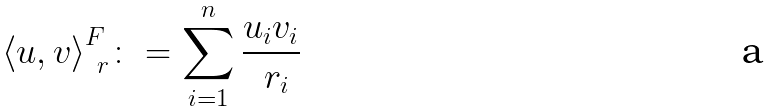<formula> <loc_0><loc_0><loc_500><loc_500>\langle u , v { \rangle } ^ { F } _ { \ r } \colon = \sum _ { i = 1 } ^ { n } \frac { u _ { i } v _ { i } } { \ r _ { i } }</formula> 